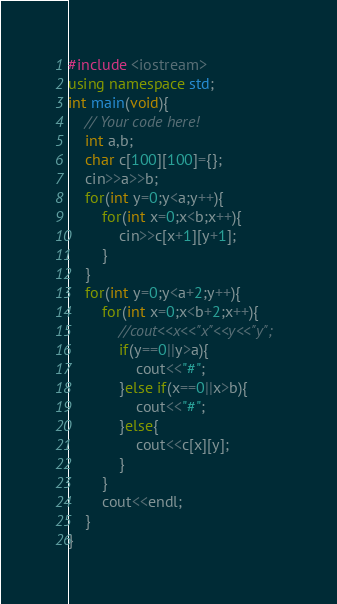Convert code to text. <code><loc_0><loc_0><loc_500><loc_500><_C++_>#include <iostream>
using namespace std;
int main(void){
    // Your code here!
    int a,b;
    char c[100][100]={};
    cin>>a>>b;
    for(int y=0;y<a;y++){
        for(int x=0;x<b;x++){
            cin>>c[x+1][y+1];
        }
    }
    for(int y=0;y<a+2;y++){
        for(int x=0;x<b+2;x++){
            //cout<<x<<"x"<<y<<"y";
            if(y==0||y>a){
                cout<<"#";
            }else if(x==0||x>b){
                cout<<"#";
            }else{
                cout<<c[x][y];
            }
        }
        cout<<endl;
    }
}
</code> 